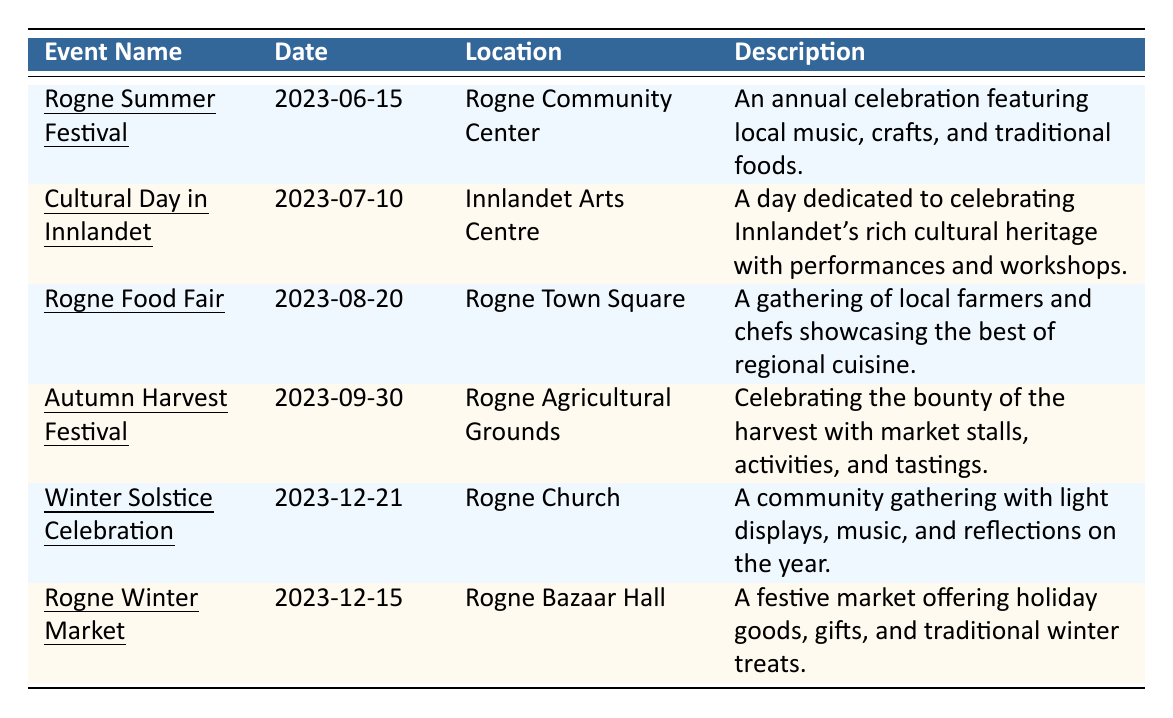What is the date of the Rogne Summer Festival? The table lists "Rogne Summer Festival" under the "Event Name" column, and the corresponding date is found in the same row under the "Date" column, which is 2023-06-15.
Answer: 2023-06-15 Where is the Autumn Harvest Festival held? The "Location" column for "Autumn Harvest Festival" shows "Rogne Agricultural Grounds," which indicates where the event takes place.
Answer: Rogne Agricultural Grounds How many events are scheduled in the month of December? From the table, there are two events listed in December: "Winter Solstice Celebration" and "Rogne Winter Market." Thus, the total number is 2.
Answer: 2 Is there an event dedicated to showcasing local cuisine? "Rogne Food Fair" in the table explicitly mentions it involves local farmers and chefs showcasing regional cuisine, confirming the presence of such an event.
Answer: Yes What is the earliest event listed in the schedule? Comparing the dates provided in the table, the earliest date is 2023-06-15 for the Rogne Summer Festival, making it the first event.
Answer: Rogne Summer Festival What location hosts the event on July 10, and what is the name of the event? The event on July 10 is "Cultural Day in Innlandet," and it is held at the "Innlandet Arts Centre," as indicated in their respective columns.
Answer: Cultural Day in Innlandet at Innlandet Arts Centre What type of activities are included in the Autumn Harvest Festival? The table's description for "Autumn Harvest Festival" mentions activities along with market stalls and tastings, suggesting various engagement opportunities at the event.
Answer: Market stalls, activities, and tastings How many festivals are there that feature crafts or performances? "Rogne Summer Festival" features local crafts, and "Cultural Day in Innlandet" focuses on performances. Adding these gives a total of 2 festivals.
Answer: 2 Is the Rogne Winter Market before the Winter Solstice Celebration? The tables show that the Rogne Winter Market is scheduled for 2023-12-15, while the Winter Solstice Celebration is on 2023-12-21, indicating the market occurs first.
Answer: Yes What is the primary focus of the "Winter Solstice Celebration"? According to the description for "Winter Solstice Celebration," it focuses on community gathering with light displays, music, and reflections on the year.
Answer: Community gathering with light displays, music, and reflections 